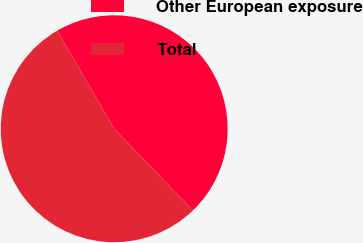Convert chart. <chart><loc_0><loc_0><loc_500><loc_500><pie_chart><fcel>Other European exposure<fcel>Total<nl><fcel>46.15%<fcel>53.85%<nl></chart> 